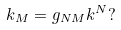<formula> <loc_0><loc_0><loc_500><loc_500>k _ { M } = g _ { N M } k ^ { N } ?</formula> 